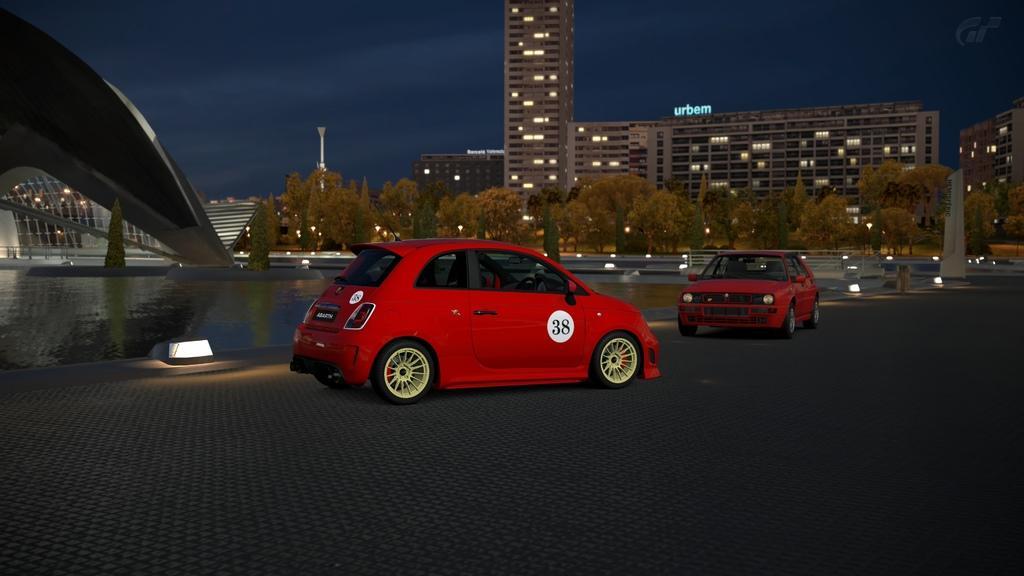Can you describe this image briefly? In the picture we can see a two cars on the path which are red in color and in the background we can see a water, building, lights, poles and a sky. 